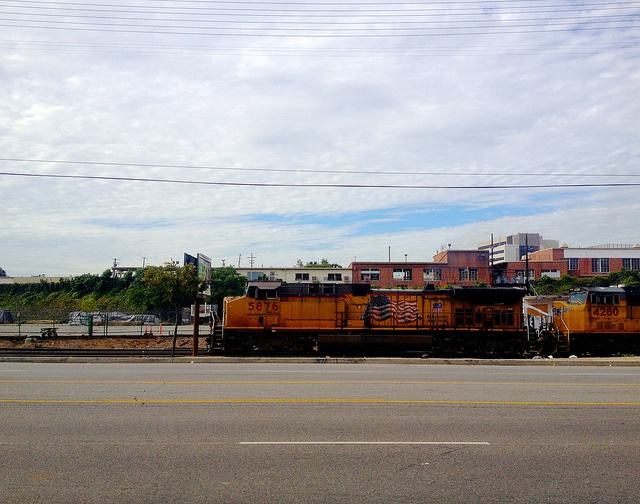Describe the objects in this image and their specific colors. I can see train in lightgray, black, maroon, and brown tones and car in lightgray, gray, black, and darkblue tones in this image. 